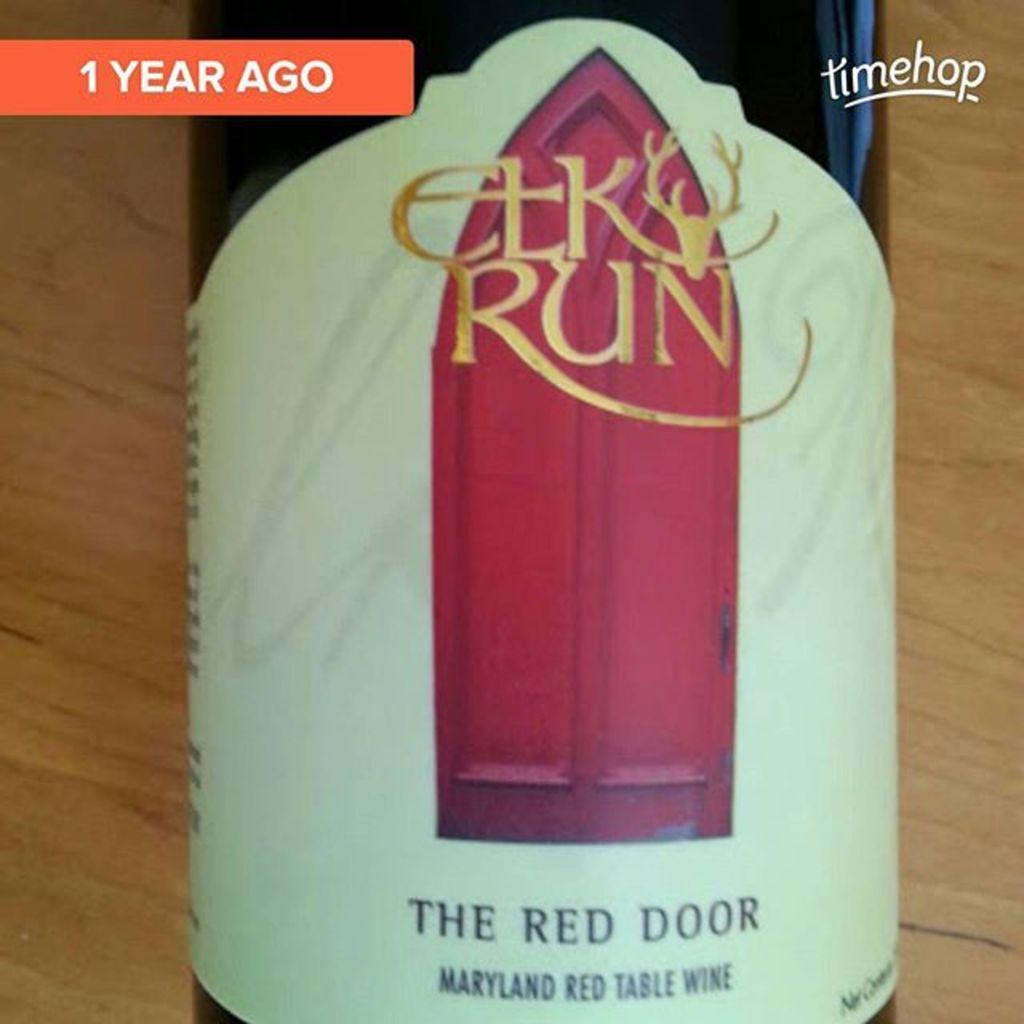What is the wine brand?
Your response must be concise. Elk run. 